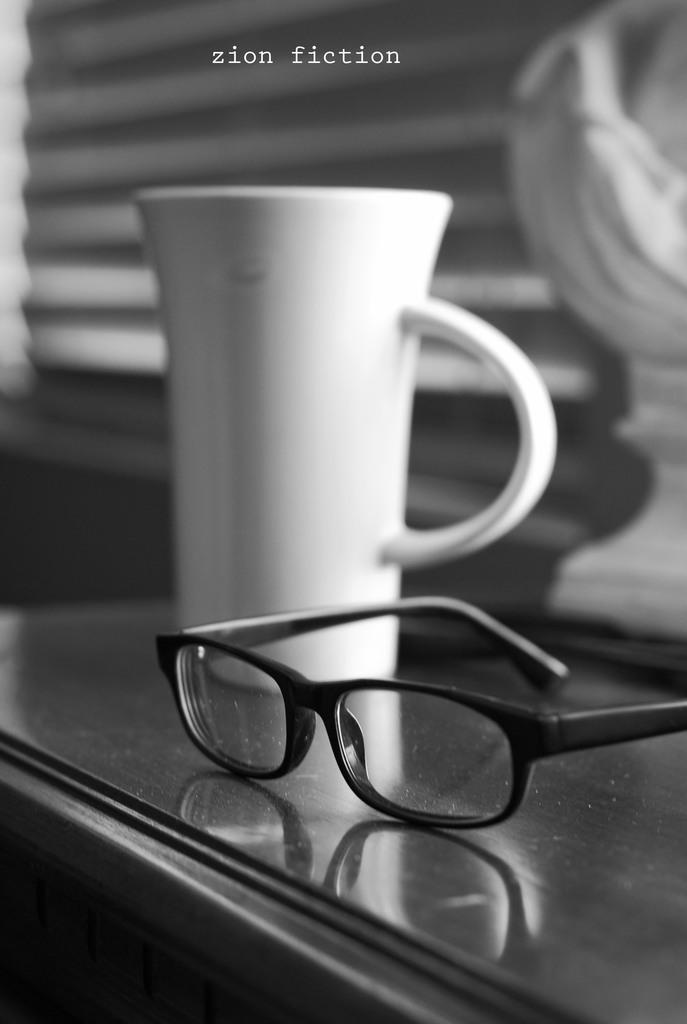Please provide a concise description of this image. In this image I can see a table on which I can see a white colored cup and black colored spectacles. In the background I can see few blurry objects. 